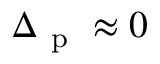Convert formula to latex. <formula><loc_0><loc_0><loc_500><loc_500>\Delta _ { p } \approx 0</formula> 